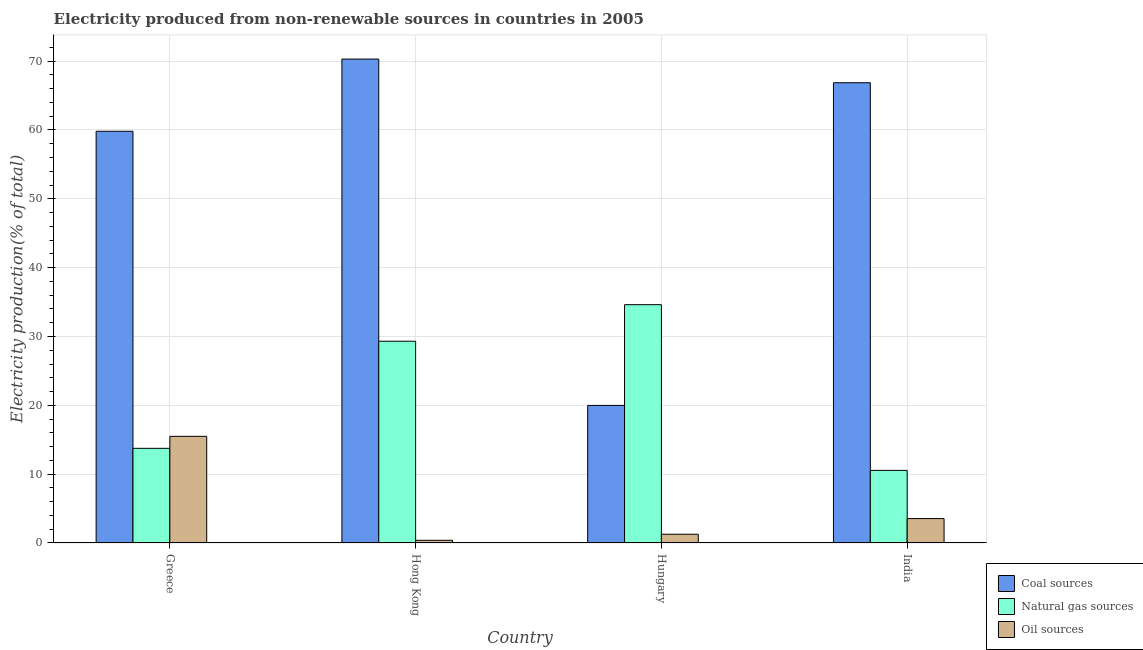How many different coloured bars are there?
Ensure brevity in your answer.  3. How many groups of bars are there?
Your answer should be compact. 4. Are the number of bars per tick equal to the number of legend labels?
Provide a succinct answer. Yes. Are the number of bars on each tick of the X-axis equal?
Make the answer very short. Yes. How many bars are there on the 3rd tick from the left?
Your answer should be very brief. 3. How many bars are there on the 4th tick from the right?
Offer a very short reply. 3. What is the label of the 4th group of bars from the left?
Your answer should be compact. India. What is the percentage of electricity produced by oil sources in Hong Kong?
Give a very brief answer. 0.39. Across all countries, what is the maximum percentage of electricity produced by coal?
Your answer should be compact. 70.3. Across all countries, what is the minimum percentage of electricity produced by oil sources?
Keep it short and to the point. 0.39. In which country was the percentage of electricity produced by coal maximum?
Keep it short and to the point. Hong Kong. In which country was the percentage of electricity produced by coal minimum?
Ensure brevity in your answer.  Hungary. What is the total percentage of electricity produced by coal in the graph?
Keep it short and to the point. 216.95. What is the difference between the percentage of electricity produced by oil sources in Greece and that in Hungary?
Your answer should be compact. 14.22. What is the difference between the percentage of electricity produced by natural gas in Hungary and the percentage of electricity produced by oil sources in Hong Kong?
Offer a terse response. 34.23. What is the average percentage of electricity produced by coal per country?
Keep it short and to the point. 54.24. What is the difference between the percentage of electricity produced by oil sources and percentage of electricity produced by natural gas in Hungary?
Provide a short and direct response. -33.35. In how many countries, is the percentage of electricity produced by coal greater than 20 %?
Keep it short and to the point. 3. What is the ratio of the percentage of electricity produced by coal in Greece to that in India?
Offer a terse response. 0.89. Is the difference between the percentage of electricity produced by oil sources in Greece and India greater than the difference between the percentage of electricity produced by coal in Greece and India?
Your answer should be compact. Yes. What is the difference between the highest and the second highest percentage of electricity produced by natural gas?
Offer a very short reply. 5.31. What is the difference between the highest and the lowest percentage of electricity produced by natural gas?
Make the answer very short. 24.08. In how many countries, is the percentage of electricity produced by natural gas greater than the average percentage of electricity produced by natural gas taken over all countries?
Offer a very short reply. 2. Is the sum of the percentage of electricity produced by coal in Greece and Hong Kong greater than the maximum percentage of electricity produced by oil sources across all countries?
Provide a succinct answer. Yes. What does the 2nd bar from the left in Hong Kong represents?
Make the answer very short. Natural gas sources. What does the 3rd bar from the right in Greece represents?
Your answer should be compact. Coal sources. Is it the case that in every country, the sum of the percentage of electricity produced by coal and percentage of electricity produced by natural gas is greater than the percentage of electricity produced by oil sources?
Ensure brevity in your answer.  Yes. How many countries are there in the graph?
Your answer should be compact. 4. What is the difference between two consecutive major ticks on the Y-axis?
Give a very brief answer. 10. Are the values on the major ticks of Y-axis written in scientific E-notation?
Make the answer very short. No. Does the graph contain grids?
Your response must be concise. Yes. Where does the legend appear in the graph?
Give a very brief answer. Bottom right. How many legend labels are there?
Your answer should be very brief. 3. How are the legend labels stacked?
Your response must be concise. Vertical. What is the title of the graph?
Your answer should be very brief. Electricity produced from non-renewable sources in countries in 2005. Does "Agriculture" appear as one of the legend labels in the graph?
Give a very brief answer. No. What is the label or title of the Y-axis?
Your response must be concise. Electricity production(% of total). What is the Electricity production(% of total) in Coal sources in Greece?
Give a very brief answer. 59.81. What is the Electricity production(% of total) in Natural gas sources in Greece?
Give a very brief answer. 13.75. What is the Electricity production(% of total) of Oil sources in Greece?
Keep it short and to the point. 15.49. What is the Electricity production(% of total) in Coal sources in Hong Kong?
Your response must be concise. 70.3. What is the Electricity production(% of total) in Natural gas sources in Hong Kong?
Your answer should be compact. 29.31. What is the Electricity production(% of total) of Oil sources in Hong Kong?
Your response must be concise. 0.39. What is the Electricity production(% of total) of Coal sources in Hungary?
Offer a terse response. 19.99. What is the Electricity production(% of total) of Natural gas sources in Hungary?
Ensure brevity in your answer.  34.62. What is the Electricity production(% of total) of Oil sources in Hungary?
Your answer should be very brief. 1.27. What is the Electricity production(% of total) in Coal sources in India?
Ensure brevity in your answer.  66.86. What is the Electricity production(% of total) of Natural gas sources in India?
Offer a very short reply. 10.55. What is the Electricity production(% of total) of Oil sources in India?
Keep it short and to the point. 3.54. Across all countries, what is the maximum Electricity production(% of total) in Coal sources?
Offer a terse response. 70.3. Across all countries, what is the maximum Electricity production(% of total) in Natural gas sources?
Ensure brevity in your answer.  34.62. Across all countries, what is the maximum Electricity production(% of total) of Oil sources?
Keep it short and to the point. 15.49. Across all countries, what is the minimum Electricity production(% of total) in Coal sources?
Give a very brief answer. 19.99. Across all countries, what is the minimum Electricity production(% of total) in Natural gas sources?
Your answer should be compact. 10.55. Across all countries, what is the minimum Electricity production(% of total) in Oil sources?
Provide a short and direct response. 0.39. What is the total Electricity production(% of total) of Coal sources in the graph?
Keep it short and to the point. 216.95. What is the total Electricity production(% of total) in Natural gas sources in the graph?
Your answer should be very brief. 88.23. What is the total Electricity production(% of total) of Oil sources in the graph?
Ensure brevity in your answer.  20.7. What is the difference between the Electricity production(% of total) in Coal sources in Greece and that in Hong Kong?
Ensure brevity in your answer.  -10.49. What is the difference between the Electricity production(% of total) in Natural gas sources in Greece and that in Hong Kong?
Offer a very short reply. -15.56. What is the difference between the Electricity production(% of total) in Oil sources in Greece and that in Hong Kong?
Make the answer very short. 15.1. What is the difference between the Electricity production(% of total) in Coal sources in Greece and that in Hungary?
Ensure brevity in your answer.  39.82. What is the difference between the Electricity production(% of total) of Natural gas sources in Greece and that in Hungary?
Your answer should be very brief. -20.87. What is the difference between the Electricity production(% of total) in Oil sources in Greece and that in Hungary?
Provide a succinct answer. 14.22. What is the difference between the Electricity production(% of total) of Coal sources in Greece and that in India?
Provide a short and direct response. -7.05. What is the difference between the Electricity production(% of total) in Natural gas sources in Greece and that in India?
Your answer should be compact. 3.2. What is the difference between the Electricity production(% of total) in Oil sources in Greece and that in India?
Keep it short and to the point. 11.95. What is the difference between the Electricity production(% of total) in Coal sources in Hong Kong and that in Hungary?
Your answer should be very brief. 50.31. What is the difference between the Electricity production(% of total) in Natural gas sources in Hong Kong and that in Hungary?
Your answer should be compact. -5.31. What is the difference between the Electricity production(% of total) of Oil sources in Hong Kong and that in Hungary?
Ensure brevity in your answer.  -0.88. What is the difference between the Electricity production(% of total) of Coal sources in Hong Kong and that in India?
Provide a short and direct response. 3.44. What is the difference between the Electricity production(% of total) of Natural gas sources in Hong Kong and that in India?
Your answer should be compact. 18.76. What is the difference between the Electricity production(% of total) of Oil sources in Hong Kong and that in India?
Ensure brevity in your answer.  -3.15. What is the difference between the Electricity production(% of total) of Coal sources in Hungary and that in India?
Give a very brief answer. -46.87. What is the difference between the Electricity production(% of total) of Natural gas sources in Hungary and that in India?
Give a very brief answer. 24.08. What is the difference between the Electricity production(% of total) of Oil sources in Hungary and that in India?
Keep it short and to the point. -2.27. What is the difference between the Electricity production(% of total) in Coal sources in Greece and the Electricity production(% of total) in Natural gas sources in Hong Kong?
Offer a very short reply. 30.5. What is the difference between the Electricity production(% of total) of Coal sources in Greece and the Electricity production(% of total) of Oil sources in Hong Kong?
Make the answer very short. 59.42. What is the difference between the Electricity production(% of total) in Natural gas sources in Greece and the Electricity production(% of total) in Oil sources in Hong Kong?
Provide a short and direct response. 13.36. What is the difference between the Electricity production(% of total) in Coal sources in Greece and the Electricity production(% of total) in Natural gas sources in Hungary?
Your answer should be compact. 25.19. What is the difference between the Electricity production(% of total) in Coal sources in Greece and the Electricity production(% of total) in Oil sources in Hungary?
Make the answer very short. 58.54. What is the difference between the Electricity production(% of total) in Natural gas sources in Greece and the Electricity production(% of total) in Oil sources in Hungary?
Provide a short and direct response. 12.48. What is the difference between the Electricity production(% of total) of Coal sources in Greece and the Electricity production(% of total) of Natural gas sources in India?
Your response must be concise. 49.26. What is the difference between the Electricity production(% of total) of Coal sources in Greece and the Electricity production(% of total) of Oil sources in India?
Your answer should be very brief. 56.27. What is the difference between the Electricity production(% of total) of Natural gas sources in Greece and the Electricity production(% of total) of Oil sources in India?
Give a very brief answer. 10.21. What is the difference between the Electricity production(% of total) in Coal sources in Hong Kong and the Electricity production(% of total) in Natural gas sources in Hungary?
Offer a terse response. 35.68. What is the difference between the Electricity production(% of total) in Coal sources in Hong Kong and the Electricity production(% of total) in Oil sources in Hungary?
Ensure brevity in your answer.  69.02. What is the difference between the Electricity production(% of total) of Natural gas sources in Hong Kong and the Electricity production(% of total) of Oil sources in Hungary?
Keep it short and to the point. 28.04. What is the difference between the Electricity production(% of total) in Coal sources in Hong Kong and the Electricity production(% of total) in Natural gas sources in India?
Your response must be concise. 59.75. What is the difference between the Electricity production(% of total) of Coal sources in Hong Kong and the Electricity production(% of total) of Oil sources in India?
Your answer should be very brief. 66.75. What is the difference between the Electricity production(% of total) in Natural gas sources in Hong Kong and the Electricity production(% of total) in Oil sources in India?
Provide a succinct answer. 25.77. What is the difference between the Electricity production(% of total) of Coal sources in Hungary and the Electricity production(% of total) of Natural gas sources in India?
Your response must be concise. 9.44. What is the difference between the Electricity production(% of total) in Coal sources in Hungary and the Electricity production(% of total) in Oil sources in India?
Your answer should be very brief. 16.44. What is the difference between the Electricity production(% of total) in Natural gas sources in Hungary and the Electricity production(% of total) in Oil sources in India?
Your answer should be very brief. 31.08. What is the average Electricity production(% of total) in Coal sources per country?
Offer a very short reply. 54.24. What is the average Electricity production(% of total) in Natural gas sources per country?
Keep it short and to the point. 22.06. What is the average Electricity production(% of total) in Oil sources per country?
Give a very brief answer. 5.18. What is the difference between the Electricity production(% of total) of Coal sources and Electricity production(% of total) of Natural gas sources in Greece?
Provide a short and direct response. 46.06. What is the difference between the Electricity production(% of total) of Coal sources and Electricity production(% of total) of Oil sources in Greece?
Give a very brief answer. 44.32. What is the difference between the Electricity production(% of total) in Natural gas sources and Electricity production(% of total) in Oil sources in Greece?
Give a very brief answer. -1.74. What is the difference between the Electricity production(% of total) in Coal sources and Electricity production(% of total) in Natural gas sources in Hong Kong?
Provide a short and direct response. 40.99. What is the difference between the Electricity production(% of total) in Coal sources and Electricity production(% of total) in Oil sources in Hong Kong?
Keep it short and to the point. 69.9. What is the difference between the Electricity production(% of total) of Natural gas sources and Electricity production(% of total) of Oil sources in Hong Kong?
Your response must be concise. 28.92. What is the difference between the Electricity production(% of total) in Coal sources and Electricity production(% of total) in Natural gas sources in Hungary?
Provide a short and direct response. -14.64. What is the difference between the Electricity production(% of total) of Coal sources and Electricity production(% of total) of Oil sources in Hungary?
Make the answer very short. 18.71. What is the difference between the Electricity production(% of total) in Natural gas sources and Electricity production(% of total) in Oil sources in Hungary?
Your response must be concise. 33.35. What is the difference between the Electricity production(% of total) in Coal sources and Electricity production(% of total) in Natural gas sources in India?
Offer a terse response. 56.31. What is the difference between the Electricity production(% of total) in Coal sources and Electricity production(% of total) in Oil sources in India?
Provide a succinct answer. 63.32. What is the difference between the Electricity production(% of total) in Natural gas sources and Electricity production(% of total) in Oil sources in India?
Your response must be concise. 7. What is the ratio of the Electricity production(% of total) in Coal sources in Greece to that in Hong Kong?
Make the answer very short. 0.85. What is the ratio of the Electricity production(% of total) of Natural gas sources in Greece to that in Hong Kong?
Make the answer very short. 0.47. What is the ratio of the Electricity production(% of total) of Oil sources in Greece to that in Hong Kong?
Offer a very short reply. 39.45. What is the ratio of the Electricity production(% of total) in Coal sources in Greece to that in Hungary?
Ensure brevity in your answer.  2.99. What is the ratio of the Electricity production(% of total) in Natural gas sources in Greece to that in Hungary?
Your response must be concise. 0.4. What is the ratio of the Electricity production(% of total) of Oil sources in Greece to that in Hungary?
Offer a very short reply. 12.18. What is the ratio of the Electricity production(% of total) of Coal sources in Greece to that in India?
Your response must be concise. 0.89. What is the ratio of the Electricity production(% of total) of Natural gas sources in Greece to that in India?
Offer a terse response. 1.3. What is the ratio of the Electricity production(% of total) in Oil sources in Greece to that in India?
Make the answer very short. 4.37. What is the ratio of the Electricity production(% of total) in Coal sources in Hong Kong to that in Hungary?
Your answer should be very brief. 3.52. What is the ratio of the Electricity production(% of total) of Natural gas sources in Hong Kong to that in Hungary?
Your response must be concise. 0.85. What is the ratio of the Electricity production(% of total) of Oil sources in Hong Kong to that in Hungary?
Offer a very short reply. 0.31. What is the ratio of the Electricity production(% of total) in Coal sources in Hong Kong to that in India?
Make the answer very short. 1.05. What is the ratio of the Electricity production(% of total) in Natural gas sources in Hong Kong to that in India?
Make the answer very short. 2.78. What is the ratio of the Electricity production(% of total) in Oil sources in Hong Kong to that in India?
Provide a succinct answer. 0.11. What is the ratio of the Electricity production(% of total) of Coal sources in Hungary to that in India?
Keep it short and to the point. 0.3. What is the ratio of the Electricity production(% of total) of Natural gas sources in Hungary to that in India?
Ensure brevity in your answer.  3.28. What is the ratio of the Electricity production(% of total) in Oil sources in Hungary to that in India?
Provide a succinct answer. 0.36. What is the difference between the highest and the second highest Electricity production(% of total) in Coal sources?
Offer a very short reply. 3.44. What is the difference between the highest and the second highest Electricity production(% of total) in Natural gas sources?
Give a very brief answer. 5.31. What is the difference between the highest and the second highest Electricity production(% of total) of Oil sources?
Ensure brevity in your answer.  11.95. What is the difference between the highest and the lowest Electricity production(% of total) of Coal sources?
Provide a succinct answer. 50.31. What is the difference between the highest and the lowest Electricity production(% of total) in Natural gas sources?
Keep it short and to the point. 24.08. What is the difference between the highest and the lowest Electricity production(% of total) of Oil sources?
Provide a short and direct response. 15.1. 